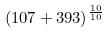Convert formula to latex. <formula><loc_0><loc_0><loc_500><loc_500>( 1 0 7 + 3 9 3 ) ^ { \frac { 1 0 } { 1 0 } }</formula> 